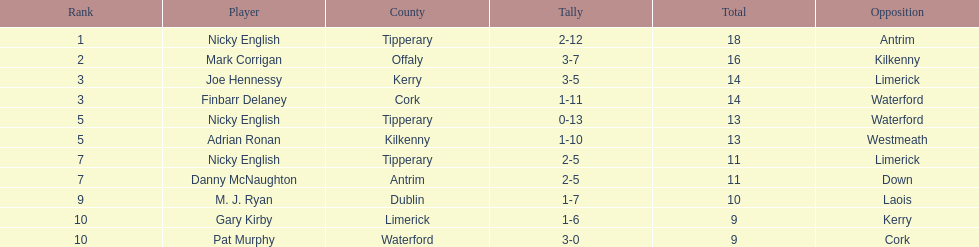What was the combined total of nicky english and mark corrigan? 34. 